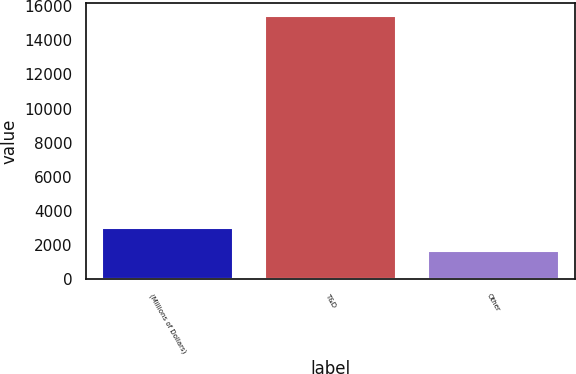<chart> <loc_0><loc_0><loc_500><loc_500><bar_chart><fcel>(Millions of Dollars)<fcel>T&D<fcel>Other<nl><fcel>3026.4<fcel>15414<fcel>1650<nl></chart> 